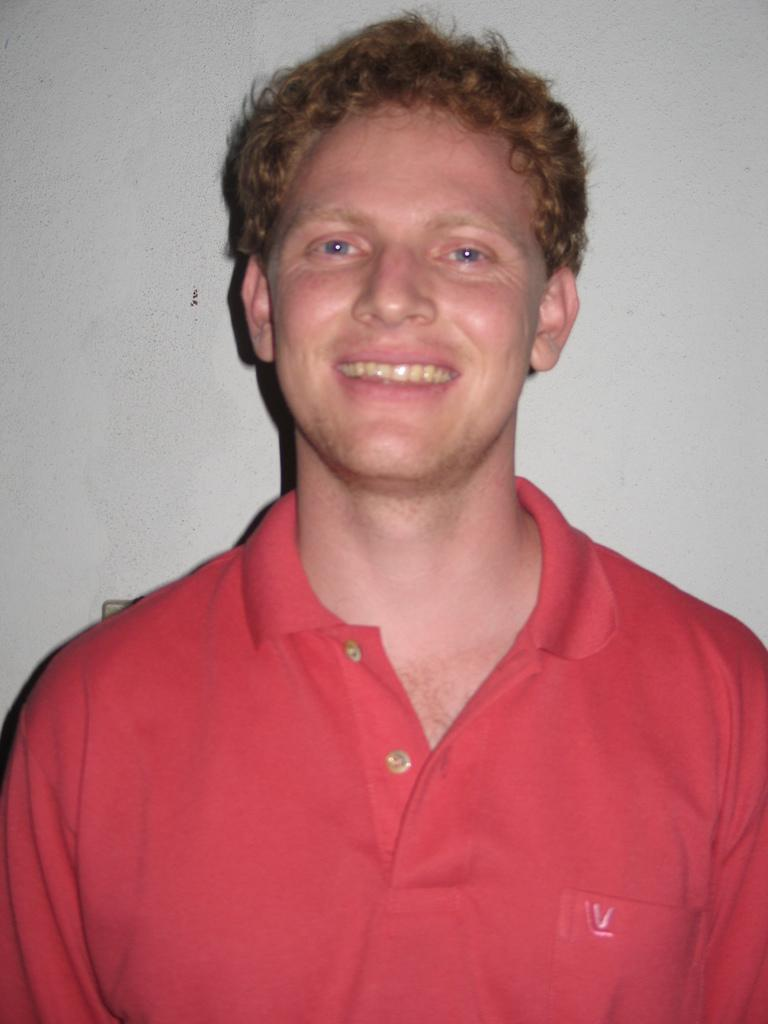What is the main subject of the image? There is a person in the image. What is the person's facial expression? The person is smiling. What color is the person's t-shirt? The person is wearing a red t-shirt. What color is the background of the image? The background of the image is white. What type of toothbrush is the person using in the image? There is no toothbrush present in the image. What tools might the person be using as a carpenter in the image? There is no indication that the person is a carpenter or using any tools in the image. 